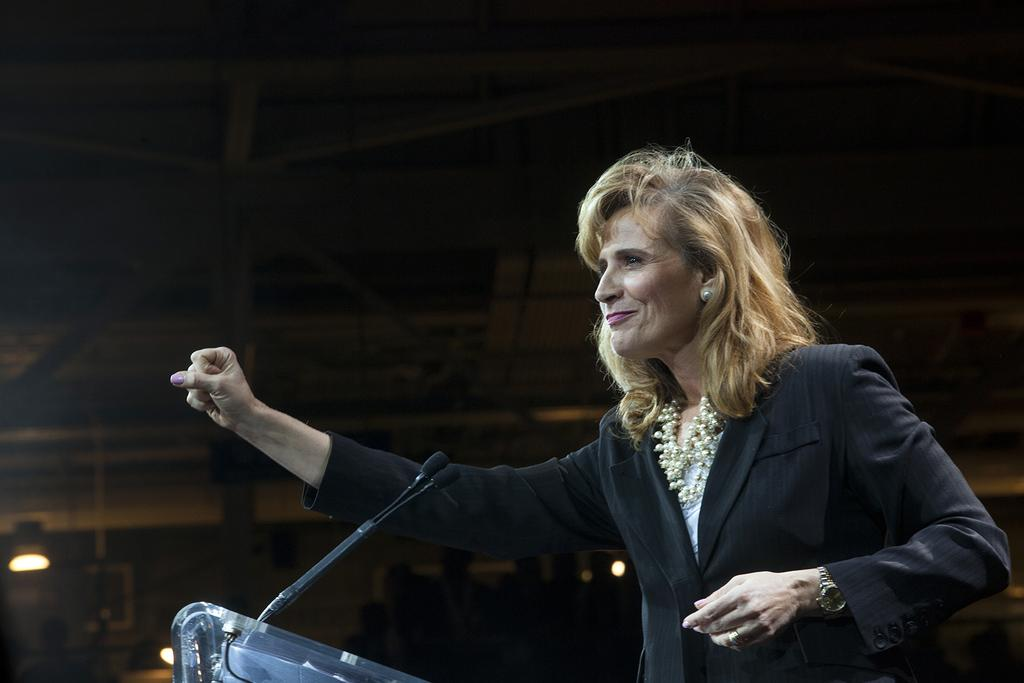Who is the main subject in the image? There is a woman in the image. What is the woman wearing? The woman is wearing a black suit. What is the woman doing in the image? The woman is standing at a speech desk and giving a speech. How is the woman's expression in the image? The woman is smiling. What can be seen in the background of the image? There is a dark background in the image. What type of notebook is the woman using to write her speech in the image? There is no notebook visible in the image; the woman is giving a speech without any visible notes. 